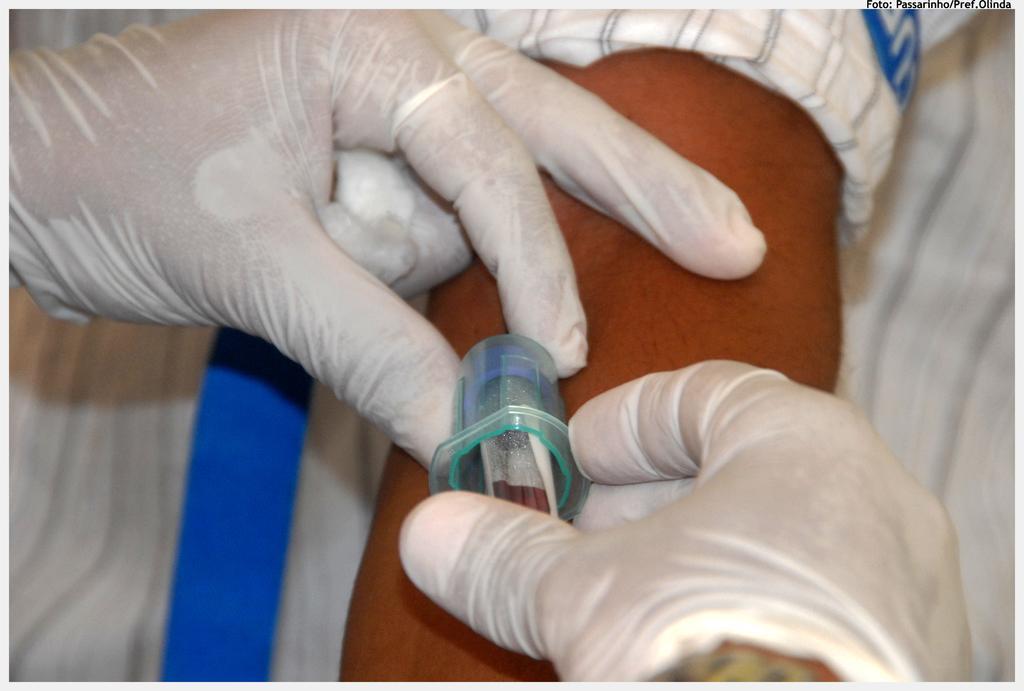In one or two sentences, can you explain what this image depicts? In this image I can see a person is holding a syringe in hand and one person's hand. This image is taken may be in a room. 